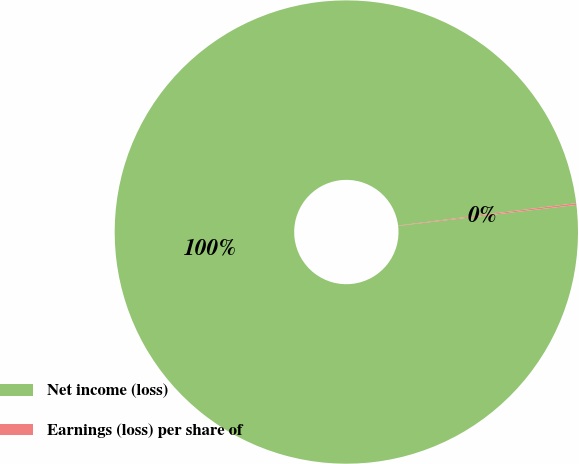Convert chart to OTSL. <chart><loc_0><loc_0><loc_500><loc_500><pie_chart><fcel>Net income (loss)<fcel>Earnings (loss) per share of<nl><fcel>99.88%<fcel>0.12%<nl></chart> 